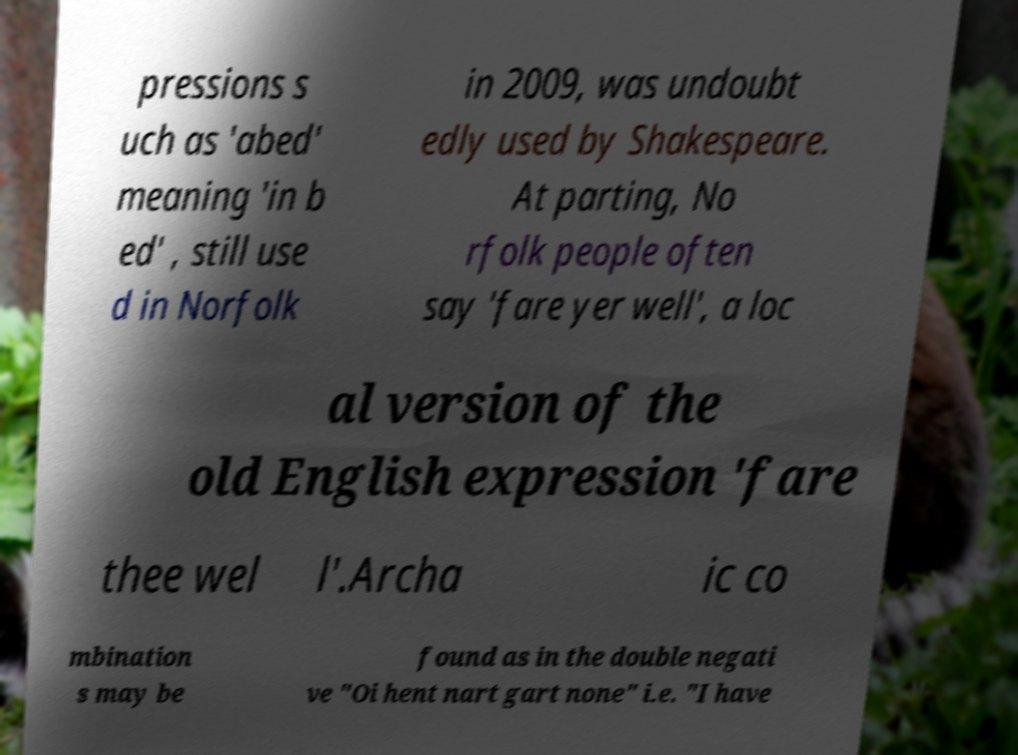Can you read and provide the text displayed in the image?This photo seems to have some interesting text. Can you extract and type it out for me? pressions s uch as 'abed' meaning 'in b ed' , still use d in Norfolk in 2009, was undoubt edly used by Shakespeare. At parting, No rfolk people often say 'fare yer well', a loc al version of the old English expression 'fare thee wel l'.Archa ic co mbination s may be found as in the double negati ve "Oi hent nart gart none" i.e. "I have 